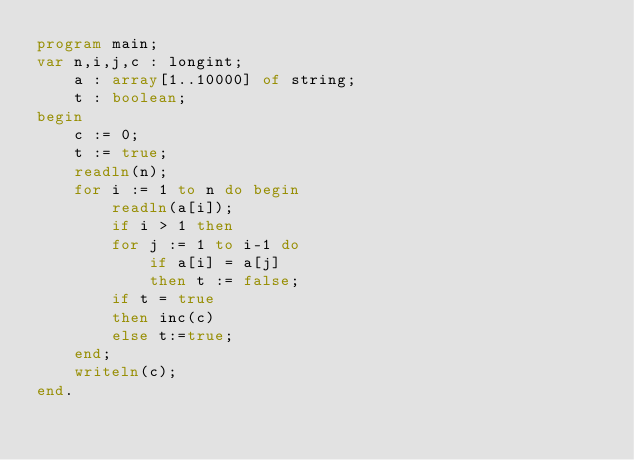Convert code to text. <code><loc_0><loc_0><loc_500><loc_500><_Pascal_>program main;
var n,i,j,c : longint;
    a : array[1..10000] of string;
    t : boolean;
begin
    c := 0;
    t := true;
    readln(n);
    for i := 1 to n do begin
        readln(a[i]);
        if i > 1 then
        for j := 1 to i-1 do
            if a[i] = a[j]
            then t := false;
        if t = true
        then inc(c)
        else t:=true;
    end;
    writeln(c);
end.</code> 